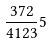Convert formula to latex. <formula><loc_0><loc_0><loc_500><loc_500>\frac { 3 7 2 } { 4 1 2 3 } 5</formula> 